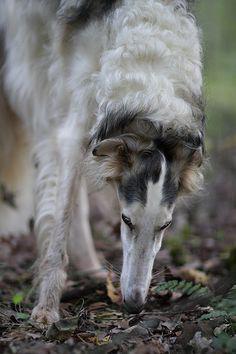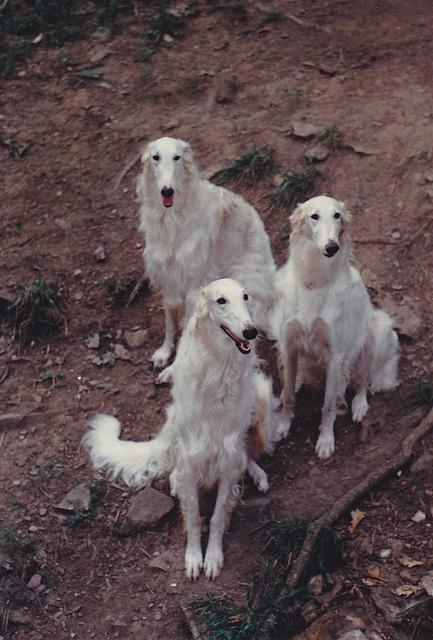The first image is the image on the left, the second image is the image on the right. Evaluate the accuracy of this statement regarding the images: "Two hounds with left-turned faces are in the foreground of the left image, and the right image includes at least three hounds.". Is it true? Answer yes or no. No. The first image is the image on the left, the second image is the image on the right. Evaluate the accuracy of this statement regarding the images: "In one image there are two white dogs and in the other image there are three dogs.". Is it true? Answer yes or no. No. 